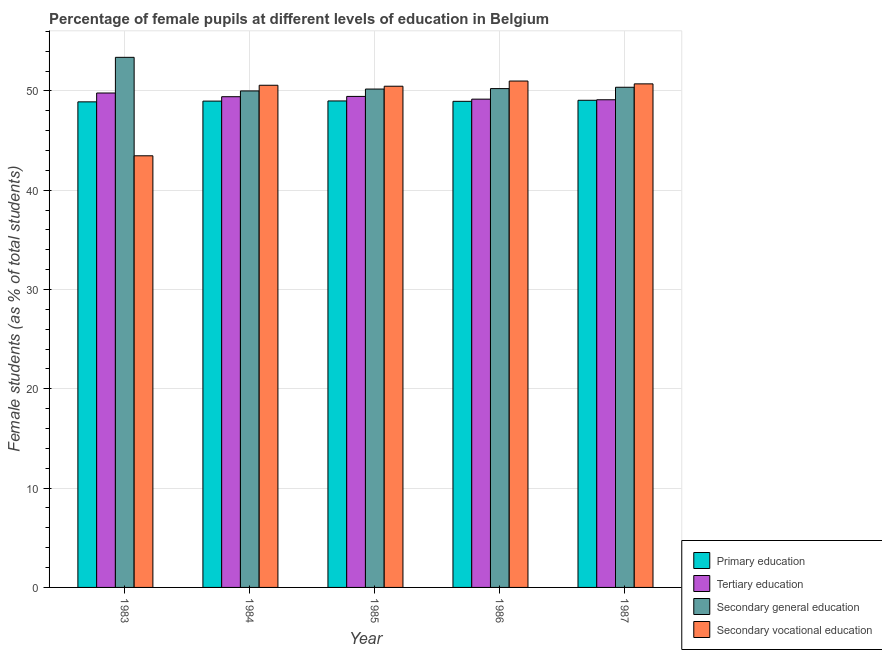How many different coloured bars are there?
Give a very brief answer. 4. How many groups of bars are there?
Provide a short and direct response. 5. Are the number of bars on each tick of the X-axis equal?
Offer a very short reply. Yes. How many bars are there on the 4th tick from the right?
Your answer should be compact. 4. What is the label of the 2nd group of bars from the left?
Provide a succinct answer. 1984. In how many cases, is the number of bars for a given year not equal to the number of legend labels?
Give a very brief answer. 0. What is the percentage of female students in primary education in 1986?
Provide a succinct answer. 48.95. Across all years, what is the maximum percentage of female students in secondary vocational education?
Your answer should be very brief. 50.99. Across all years, what is the minimum percentage of female students in primary education?
Provide a succinct answer. 48.9. In which year was the percentage of female students in primary education maximum?
Provide a succinct answer. 1987. What is the total percentage of female students in primary education in the graph?
Provide a succinct answer. 244.87. What is the difference between the percentage of female students in secondary vocational education in 1983 and that in 1986?
Provide a succinct answer. -7.53. What is the difference between the percentage of female students in tertiary education in 1983 and the percentage of female students in secondary education in 1987?
Keep it short and to the point. 0.68. What is the average percentage of female students in primary education per year?
Offer a very short reply. 48.97. In how many years, is the percentage of female students in tertiary education greater than 26 %?
Your answer should be compact. 5. What is the ratio of the percentage of female students in secondary education in 1985 to that in 1987?
Make the answer very short. 1. Is the difference between the percentage of female students in tertiary education in 1984 and 1985 greater than the difference between the percentage of female students in secondary education in 1984 and 1985?
Keep it short and to the point. No. What is the difference between the highest and the second highest percentage of female students in secondary education?
Provide a short and direct response. 3.01. What is the difference between the highest and the lowest percentage of female students in secondary vocational education?
Your response must be concise. 7.53. Is the sum of the percentage of female students in tertiary education in 1983 and 1987 greater than the maximum percentage of female students in secondary education across all years?
Provide a short and direct response. Yes. What does the 3rd bar from the left in 1986 represents?
Provide a succinct answer. Secondary general education. What does the 2nd bar from the right in 1985 represents?
Offer a terse response. Secondary general education. Are all the bars in the graph horizontal?
Ensure brevity in your answer.  No. How many years are there in the graph?
Offer a very short reply. 5. What is the difference between two consecutive major ticks on the Y-axis?
Your response must be concise. 10. Are the values on the major ticks of Y-axis written in scientific E-notation?
Ensure brevity in your answer.  No. Does the graph contain any zero values?
Your answer should be compact. No. Does the graph contain grids?
Your response must be concise. Yes. Where does the legend appear in the graph?
Provide a short and direct response. Bottom right. How many legend labels are there?
Make the answer very short. 4. How are the legend labels stacked?
Make the answer very short. Vertical. What is the title of the graph?
Give a very brief answer. Percentage of female pupils at different levels of education in Belgium. What is the label or title of the X-axis?
Provide a short and direct response. Year. What is the label or title of the Y-axis?
Give a very brief answer. Female students (as % of total students). What is the Female students (as % of total students) in Primary education in 1983?
Offer a terse response. 48.9. What is the Female students (as % of total students) in Tertiary education in 1983?
Your answer should be very brief. 49.79. What is the Female students (as % of total students) in Secondary general education in 1983?
Provide a succinct answer. 53.38. What is the Female students (as % of total students) in Secondary vocational education in 1983?
Your response must be concise. 43.47. What is the Female students (as % of total students) in Primary education in 1984?
Keep it short and to the point. 48.97. What is the Female students (as % of total students) of Tertiary education in 1984?
Provide a short and direct response. 49.42. What is the Female students (as % of total students) in Secondary general education in 1984?
Ensure brevity in your answer.  50. What is the Female students (as % of total students) of Secondary vocational education in 1984?
Make the answer very short. 50.57. What is the Female students (as % of total students) in Primary education in 1985?
Offer a terse response. 48.99. What is the Female students (as % of total students) of Tertiary education in 1985?
Ensure brevity in your answer.  49.45. What is the Female students (as % of total students) in Secondary general education in 1985?
Your answer should be very brief. 50.19. What is the Female students (as % of total students) of Secondary vocational education in 1985?
Offer a terse response. 50.47. What is the Female students (as % of total students) in Primary education in 1986?
Your answer should be very brief. 48.95. What is the Female students (as % of total students) in Tertiary education in 1986?
Provide a short and direct response. 49.17. What is the Female students (as % of total students) in Secondary general education in 1986?
Your answer should be very brief. 50.23. What is the Female students (as % of total students) of Secondary vocational education in 1986?
Your answer should be very brief. 50.99. What is the Female students (as % of total students) of Primary education in 1987?
Your answer should be very brief. 49.06. What is the Female students (as % of total students) in Tertiary education in 1987?
Give a very brief answer. 49.11. What is the Female students (as % of total students) of Secondary general education in 1987?
Your answer should be compact. 50.37. What is the Female students (as % of total students) in Secondary vocational education in 1987?
Offer a very short reply. 50.71. Across all years, what is the maximum Female students (as % of total students) of Primary education?
Your answer should be very brief. 49.06. Across all years, what is the maximum Female students (as % of total students) in Tertiary education?
Your response must be concise. 49.79. Across all years, what is the maximum Female students (as % of total students) in Secondary general education?
Offer a terse response. 53.38. Across all years, what is the maximum Female students (as % of total students) in Secondary vocational education?
Provide a short and direct response. 50.99. Across all years, what is the minimum Female students (as % of total students) in Primary education?
Make the answer very short. 48.9. Across all years, what is the minimum Female students (as % of total students) in Tertiary education?
Your answer should be very brief. 49.11. Across all years, what is the minimum Female students (as % of total students) in Secondary general education?
Provide a succinct answer. 50. Across all years, what is the minimum Female students (as % of total students) in Secondary vocational education?
Ensure brevity in your answer.  43.47. What is the total Female students (as % of total students) in Primary education in the graph?
Offer a very short reply. 244.87. What is the total Female students (as % of total students) in Tertiary education in the graph?
Give a very brief answer. 246.93. What is the total Female students (as % of total students) in Secondary general education in the graph?
Keep it short and to the point. 254.16. What is the total Female students (as % of total students) of Secondary vocational education in the graph?
Provide a succinct answer. 246.21. What is the difference between the Female students (as % of total students) of Primary education in 1983 and that in 1984?
Offer a very short reply. -0.08. What is the difference between the Female students (as % of total students) in Tertiary education in 1983 and that in 1984?
Keep it short and to the point. 0.37. What is the difference between the Female students (as % of total students) of Secondary general education in 1983 and that in 1984?
Keep it short and to the point. 3.38. What is the difference between the Female students (as % of total students) in Secondary vocational education in 1983 and that in 1984?
Ensure brevity in your answer.  -7.1. What is the difference between the Female students (as % of total students) of Primary education in 1983 and that in 1985?
Provide a short and direct response. -0.09. What is the difference between the Female students (as % of total students) of Tertiary education in 1983 and that in 1985?
Provide a succinct answer. 0.34. What is the difference between the Female students (as % of total students) in Secondary general education in 1983 and that in 1985?
Provide a short and direct response. 3.19. What is the difference between the Female students (as % of total students) in Secondary vocational education in 1983 and that in 1985?
Your response must be concise. -7.01. What is the difference between the Female students (as % of total students) in Primary education in 1983 and that in 1986?
Ensure brevity in your answer.  -0.05. What is the difference between the Female students (as % of total students) of Tertiary education in 1983 and that in 1986?
Ensure brevity in your answer.  0.62. What is the difference between the Female students (as % of total students) of Secondary general education in 1983 and that in 1986?
Your answer should be compact. 3.15. What is the difference between the Female students (as % of total students) in Secondary vocational education in 1983 and that in 1986?
Your answer should be compact. -7.53. What is the difference between the Female students (as % of total students) in Primary education in 1983 and that in 1987?
Your answer should be very brief. -0.16. What is the difference between the Female students (as % of total students) in Tertiary education in 1983 and that in 1987?
Provide a succinct answer. 0.68. What is the difference between the Female students (as % of total students) in Secondary general education in 1983 and that in 1987?
Give a very brief answer. 3.01. What is the difference between the Female students (as % of total students) of Secondary vocational education in 1983 and that in 1987?
Give a very brief answer. -7.24. What is the difference between the Female students (as % of total students) of Primary education in 1984 and that in 1985?
Ensure brevity in your answer.  -0.01. What is the difference between the Female students (as % of total students) in Tertiary education in 1984 and that in 1985?
Make the answer very short. -0.03. What is the difference between the Female students (as % of total students) in Secondary general education in 1984 and that in 1985?
Provide a succinct answer. -0.19. What is the difference between the Female students (as % of total students) in Secondary vocational education in 1984 and that in 1985?
Your response must be concise. 0.1. What is the difference between the Female students (as % of total students) in Primary education in 1984 and that in 1986?
Keep it short and to the point. 0.02. What is the difference between the Female students (as % of total students) in Tertiary education in 1984 and that in 1986?
Your answer should be very brief. 0.25. What is the difference between the Female students (as % of total students) in Secondary general education in 1984 and that in 1986?
Ensure brevity in your answer.  -0.23. What is the difference between the Female students (as % of total students) of Secondary vocational education in 1984 and that in 1986?
Keep it short and to the point. -0.42. What is the difference between the Female students (as % of total students) of Primary education in 1984 and that in 1987?
Your answer should be compact. -0.08. What is the difference between the Female students (as % of total students) of Tertiary education in 1984 and that in 1987?
Make the answer very short. 0.31. What is the difference between the Female students (as % of total students) in Secondary general education in 1984 and that in 1987?
Make the answer very short. -0.37. What is the difference between the Female students (as % of total students) of Secondary vocational education in 1984 and that in 1987?
Your answer should be compact. -0.14. What is the difference between the Female students (as % of total students) of Primary education in 1985 and that in 1986?
Make the answer very short. 0.04. What is the difference between the Female students (as % of total students) of Tertiary education in 1985 and that in 1986?
Provide a succinct answer. 0.28. What is the difference between the Female students (as % of total students) of Secondary general education in 1985 and that in 1986?
Ensure brevity in your answer.  -0.05. What is the difference between the Female students (as % of total students) in Secondary vocational education in 1985 and that in 1986?
Your response must be concise. -0.52. What is the difference between the Female students (as % of total students) of Primary education in 1985 and that in 1987?
Keep it short and to the point. -0.07. What is the difference between the Female students (as % of total students) in Tertiary education in 1985 and that in 1987?
Give a very brief answer. 0.34. What is the difference between the Female students (as % of total students) of Secondary general education in 1985 and that in 1987?
Your answer should be very brief. -0.18. What is the difference between the Female students (as % of total students) in Secondary vocational education in 1985 and that in 1987?
Keep it short and to the point. -0.24. What is the difference between the Female students (as % of total students) of Primary education in 1986 and that in 1987?
Give a very brief answer. -0.1. What is the difference between the Female students (as % of total students) in Tertiary education in 1986 and that in 1987?
Your answer should be very brief. 0.06. What is the difference between the Female students (as % of total students) in Secondary general education in 1986 and that in 1987?
Offer a terse response. -0.13. What is the difference between the Female students (as % of total students) in Secondary vocational education in 1986 and that in 1987?
Provide a succinct answer. 0.29. What is the difference between the Female students (as % of total students) of Primary education in 1983 and the Female students (as % of total students) of Tertiary education in 1984?
Offer a very short reply. -0.52. What is the difference between the Female students (as % of total students) in Primary education in 1983 and the Female students (as % of total students) in Secondary general education in 1984?
Make the answer very short. -1.1. What is the difference between the Female students (as % of total students) in Primary education in 1983 and the Female students (as % of total students) in Secondary vocational education in 1984?
Your answer should be compact. -1.67. What is the difference between the Female students (as % of total students) in Tertiary education in 1983 and the Female students (as % of total students) in Secondary general education in 1984?
Make the answer very short. -0.21. What is the difference between the Female students (as % of total students) of Tertiary education in 1983 and the Female students (as % of total students) of Secondary vocational education in 1984?
Provide a succinct answer. -0.78. What is the difference between the Female students (as % of total students) of Secondary general education in 1983 and the Female students (as % of total students) of Secondary vocational education in 1984?
Ensure brevity in your answer.  2.81. What is the difference between the Female students (as % of total students) in Primary education in 1983 and the Female students (as % of total students) in Tertiary education in 1985?
Keep it short and to the point. -0.55. What is the difference between the Female students (as % of total students) in Primary education in 1983 and the Female students (as % of total students) in Secondary general education in 1985?
Your answer should be compact. -1.29. What is the difference between the Female students (as % of total students) of Primary education in 1983 and the Female students (as % of total students) of Secondary vocational education in 1985?
Offer a terse response. -1.57. What is the difference between the Female students (as % of total students) in Tertiary education in 1983 and the Female students (as % of total students) in Secondary general education in 1985?
Your answer should be compact. -0.4. What is the difference between the Female students (as % of total students) of Tertiary education in 1983 and the Female students (as % of total students) of Secondary vocational education in 1985?
Offer a terse response. -0.68. What is the difference between the Female students (as % of total students) of Secondary general education in 1983 and the Female students (as % of total students) of Secondary vocational education in 1985?
Your answer should be compact. 2.91. What is the difference between the Female students (as % of total students) in Primary education in 1983 and the Female students (as % of total students) in Tertiary education in 1986?
Your answer should be very brief. -0.27. What is the difference between the Female students (as % of total students) in Primary education in 1983 and the Female students (as % of total students) in Secondary general education in 1986?
Your answer should be compact. -1.33. What is the difference between the Female students (as % of total students) in Primary education in 1983 and the Female students (as % of total students) in Secondary vocational education in 1986?
Provide a short and direct response. -2.1. What is the difference between the Female students (as % of total students) of Tertiary education in 1983 and the Female students (as % of total students) of Secondary general education in 1986?
Ensure brevity in your answer.  -0.44. What is the difference between the Female students (as % of total students) in Tertiary education in 1983 and the Female students (as % of total students) in Secondary vocational education in 1986?
Your answer should be compact. -1.21. What is the difference between the Female students (as % of total students) of Secondary general education in 1983 and the Female students (as % of total students) of Secondary vocational education in 1986?
Ensure brevity in your answer.  2.39. What is the difference between the Female students (as % of total students) of Primary education in 1983 and the Female students (as % of total students) of Tertiary education in 1987?
Offer a very short reply. -0.21. What is the difference between the Female students (as % of total students) of Primary education in 1983 and the Female students (as % of total students) of Secondary general education in 1987?
Give a very brief answer. -1.47. What is the difference between the Female students (as % of total students) in Primary education in 1983 and the Female students (as % of total students) in Secondary vocational education in 1987?
Ensure brevity in your answer.  -1.81. What is the difference between the Female students (as % of total students) in Tertiary education in 1983 and the Female students (as % of total students) in Secondary general education in 1987?
Make the answer very short. -0.58. What is the difference between the Female students (as % of total students) of Tertiary education in 1983 and the Female students (as % of total students) of Secondary vocational education in 1987?
Your response must be concise. -0.92. What is the difference between the Female students (as % of total students) of Secondary general education in 1983 and the Female students (as % of total students) of Secondary vocational education in 1987?
Make the answer very short. 2.67. What is the difference between the Female students (as % of total students) in Primary education in 1984 and the Female students (as % of total students) in Tertiary education in 1985?
Provide a short and direct response. -0.47. What is the difference between the Female students (as % of total students) of Primary education in 1984 and the Female students (as % of total students) of Secondary general education in 1985?
Ensure brevity in your answer.  -1.21. What is the difference between the Female students (as % of total students) of Primary education in 1984 and the Female students (as % of total students) of Secondary vocational education in 1985?
Give a very brief answer. -1.5. What is the difference between the Female students (as % of total students) in Tertiary education in 1984 and the Female students (as % of total students) in Secondary general education in 1985?
Give a very brief answer. -0.77. What is the difference between the Female students (as % of total students) in Tertiary education in 1984 and the Female students (as % of total students) in Secondary vocational education in 1985?
Give a very brief answer. -1.06. What is the difference between the Female students (as % of total students) of Secondary general education in 1984 and the Female students (as % of total students) of Secondary vocational education in 1985?
Ensure brevity in your answer.  -0.47. What is the difference between the Female students (as % of total students) in Primary education in 1984 and the Female students (as % of total students) in Tertiary education in 1986?
Provide a succinct answer. -0.2. What is the difference between the Female students (as % of total students) of Primary education in 1984 and the Female students (as % of total students) of Secondary general education in 1986?
Offer a terse response. -1.26. What is the difference between the Female students (as % of total students) in Primary education in 1984 and the Female students (as % of total students) in Secondary vocational education in 1986?
Keep it short and to the point. -2.02. What is the difference between the Female students (as % of total students) of Tertiary education in 1984 and the Female students (as % of total students) of Secondary general education in 1986?
Keep it short and to the point. -0.82. What is the difference between the Female students (as % of total students) in Tertiary education in 1984 and the Female students (as % of total students) in Secondary vocational education in 1986?
Provide a short and direct response. -1.58. What is the difference between the Female students (as % of total students) of Secondary general education in 1984 and the Female students (as % of total students) of Secondary vocational education in 1986?
Your response must be concise. -1. What is the difference between the Female students (as % of total students) of Primary education in 1984 and the Female students (as % of total students) of Tertiary education in 1987?
Give a very brief answer. -0.13. What is the difference between the Female students (as % of total students) in Primary education in 1984 and the Female students (as % of total students) in Secondary general education in 1987?
Your answer should be compact. -1.39. What is the difference between the Female students (as % of total students) of Primary education in 1984 and the Female students (as % of total students) of Secondary vocational education in 1987?
Offer a very short reply. -1.73. What is the difference between the Female students (as % of total students) in Tertiary education in 1984 and the Female students (as % of total students) in Secondary general education in 1987?
Your answer should be very brief. -0.95. What is the difference between the Female students (as % of total students) in Tertiary education in 1984 and the Female students (as % of total students) in Secondary vocational education in 1987?
Provide a succinct answer. -1.29. What is the difference between the Female students (as % of total students) of Secondary general education in 1984 and the Female students (as % of total students) of Secondary vocational education in 1987?
Provide a short and direct response. -0.71. What is the difference between the Female students (as % of total students) of Primary education in 1985 and the Female students (as % of total students) of Tertiary education in 1986?
Keep it short and to the point. -0.18. What is the difference between the Female students (as % of total students) of Primary education in 1985 and the Female students (as % of total students) of Secondary general education in 1986?
Keep it short and to the point. -1.24. What is the difference between the Female students (as % of total students) of Primary education in 1985 and the Female students (as % of total students) of Secondary vocational education in 1986?
Keep it short and to the point. -2.01. What is the difference between the Female students (as % of total students) of Tertiary education in 1985 and the Female students (as % of total students) of Secondary general education in 1986?
Your answer should be very brief. -0.79. What is the difference between the Female students (as % of total students) of Tertiary education in 1985 and the Female students (as % of total students) of Secondary vocational education in 1986?
Offer a very short reply. -1.55. What is the difference between the Female students (as % of total students) of Secondary general education in 1985 and the Female students (as % of total students) of Secondary vocational education in 1986?
Your answer should be very brief. -0.81. What is the difference between the Female students (as % of total students) of Primary education in 1985 and the Female students (as % of total students) of Tertiary education in 1987?
Your response must be concise. -0.12. What is the difference between the Female students (as % of total students) of Primary education in 1985 and the Female students (as % of total students) of Secondary general education in 1987?
Offer a terse response. -1.38. What is the difference between the Female students (as % of total students) in Primary education in 1985 and the Female students (as % of total students) in Secondary vocational education in 1987?
Make the answer very short. -1.72. What is the difference between the Female students (as % of total students) of Tertiary education in 1985 and the Female students (as % of total students) of Secondary general education in 1987?
Offer a very short reply. -0.92. What is the difference between the Female students (as % of total students) in Tertiary education in 1985 and the Female students (as % of total students) in Secondary vocational education in 1987?
Your response must be concise. -1.26. What is the difference between the Female students (as % of total students) in Secondary general education in 1985 and the Female students (as % of total students) in Secondary vocational education in 1987?
Ensure brevity in your answer.  -0.52. What is the difference between the Female students (as % of total students) in Primary education in 1986 and the Female students (as % of total students) in Tertiary education in 1987?
Ensure brevity in your answer.  -0.16. What is the difference between the Female students (as % of total students) in Primary education in 1986 and the Female students (as % of total students) in Secondary general education in 1987?
Provide a succinct answer. -1.42. What is the difference between the Female students (as % of total students) in Primary education in 1986 and the Female students (as % of total students) in Secondary vocational education in 1987?
Your response must be concise. -1.76. What is the difference between the Female students (as % of total students) in Tertiary education in 1986 and the Female students (as % of total students) in Secondary general education in 1987?
Keep it short and to the point. -1.2. What is the difference between the Female students (as % of total students) in Tertiary education in 1986 and the Female students (as % of total students) in Secondary vocational education in 1987?
Provide a succinct answer. -1.54. What is the difference between the Female students (as % of total students) in Secondary general education in 1986 and the Female students (as % of total students) in Secondary vocational education in 1987?
Provide a short and direct response. -0.48. What is the average Female students (as % of total students) of Primary education per year?
Make the answer very short. 48.97. What is the average Female students (as % of total students) of Tertiary education per year?
Keep it short and to the point. 49.39. What is the average Female students (as % of total students) of Secondary general education per year?
Ensure brevity in your answer.  50.83. What is the average Female students (as % of total students) of Secondary vocational education per year?
Provide a short and direct response. 49.24. In the year 1983, what is the difference between the Female students (as % of total students) of Primary education and Female students (as % of total students) of Tertiary education?
Ensure brevity in your answer.  -0.89. In the year 1983, what is the difference between the Female students (as % of total students) of Primary education and Female students (as % of total students) of Secondary general education?
Offer a terse response. -4.48. In the year 1983, what is the difference between the Female students (as % of total students) in Primary education and Female students (as % of total students) in Secondary vocational education?
Give a very brief answer. 5.43. In the year 1983, what is the difference between the Female students (as % of total students) of Tertiary education and Female students (as % of total students) of Secondary general education?
Ensure brevity in your answer.  -3.59. In the year 1983, what is the difference between the Female students (as % of total students) in Tertiary education and Female students (as % of total students) in Secondary vocational education?
Provide a succinct answer. 6.32. In the year 1983, what is the difference between the Female students (as % of total students) of Secondary general education and Female students (as % of total students) of Secondary vocational education?
Make the answer very short. 9.92. In the year 1984, what is the difference between the Female students (as % of total students) of Primary education and Female students (as % of total students) of Tertiary education?
Ensure brevity in your answer.  -0.44. In the year 1984, what is the difference between the Female students (as % of total students) of Primary education and Female students (as % of total students) of Secondary general education?
Give a very brief answer. -1.02. In the year 1984, what is the difference between the Female students (as % of total students) of Primary education and Female students (as % of total students) of Secondary vocational education?
Ensure brevity in your answer.  -1.59. In the year 1984, what is the difference between the Female students (as % of total students) in Tertiary education and Female students (as % of total students) in Secondary general education?
Provide a short and direct response. -0.58. In the year 1984, what is the difference between the Female students (as % of total students) of Tertiary education and Female students (as % of total students) of Secondary vocational education?
Your answer should be very brief. -1.15. In the year 1984, what is the difference between the Female students (as % of total students) of Secondary general education and Female students (as % of total students) of Secondary vocational education?
Your answer should be very brief. -0.57. In the year 1985, what is the difference between the Female students (as % of total students) of Primary education and Female students (as % of total students) of Tertiary education?
Provide a short and direct response. -0.46. In the year 1985, what is the difference between the Female students (as % of total students) in Primary education and Female students (as % of total students) in Secondary general education?
Offer a terse response. -1.2. In the year 1985, what is the difference between the Female students (as % of total students) in Primary education and Female students (as % of total students) in Secondary vocational education?
Offer a very short reply. -1.48. In the year 1985, what is the difference between the Female students (as % of total students) in Tertiary education and Female students (as % of total students) in Secondary general education?
Provide a succinct answer. -0.74. In the year 1985, what is the difference between the Female students (as % of total students) in Tertiary education and Female students (as % of total students) in Secondary vocational education?
Provide a short and direct response. -1.03. In the year 1985, what is the difference between the Female students (as % of total students) in Secondary general education and Female students (as % of total students) in Secondary vocational education?
Keep it short and to the point. -0.28. In the year 1986, what is the difference between the Female students (as % of total students) of Primary education and Female students (as % of total students) of Tertiary education?
Offer a very short reply. -0.22. In the year 1986, what is the difference between the Female students (as % of total students) of Primary education and Female students (as % of total students) of Secondary general education?
Your answer should be compact. -1.28. In the year 1986, what is the difference between the Female students (as % of total students) of Primary education and Female students (as % of total students) of Secondary vocational education?
Provide a short and direct response. -2.04. In the year 1986, what is the difference between the Female students (as % of total students) in Tertiary education and Female students (as % of total students) in Secondary general education?
Make the answer very short. -1.06. In the year 1986, what is the difference between the Female students (as % of total students) in Tertiary education and Female students (as % of total students) in Secondary vocational education?
Keep it short and to the point. -1.82. In the year 1986, what is the difference between the Female students (as % of total students) of Secondary general education and Female students (as % of total students) of Secondary vocational education?
Ensure brevity in your answer.  -0.76. In the year 1987, what is the difference between the Female students (as % of total students) in Primary education and Female students (as % of total students) in Tertiary education?
Make the answer very short. -0.05. In the year 1987, what is the difference between the Female students (as % of total students) in Primary education and Female students (as % of total students) in Secondary general education?
Your answer should be very brief. -1.31. In the year 1987, what is the difference between the Female students (as % of total students) in Primary education and Female students (as % of total students) in Secondary vocational education?
Make the answer very short. -1.65. In the year 1987, what is the difference between the Female students (as % of total students) in Tertiary education and Female students (as % of total students) in Secondary general education?
Your answer should be very brief. -1.26. In the year 1987, what is the difference between the Female students (as % of total students) of Tertiary education and Female students (as % of total students) of Secondary vocational education?
Give a very brief answer. -1.6. In the year 1987, what is the difference between the Female students (as % of total students) of Secondary general education and Female students (as % of total students) of Secondary vocational education?
Your answer should be compact. -0.34. What is the ratio of the Female students (as % of total students) of Tertiary education in 1983 to that in 1984?
Give a very brief answer. 1.01. What is the ratio of the Female students (as % of total students) in Secondary general education in 1983 to that in 1984?
Your answer should be very brief. 1.07. What is the ratio of the Female students (as % of total students) in Secondary vocational education in 1983 to that in 1984?
Your answer should be compact. 0.86. What is the ratio of the Female students (as % of total students) in Tertiary education in 1983 to that in 1985?
Your response must be concise. 1.01. What is the ratio of the Female students (as % of total students) of Secondary general education in 1983 to that in 1985?
Offer a very short reply. 1.06. What is the ratio of the Female students (as % of total students) of Secondary vocational education in 1983 to that in 1985?
Ensure brevity in your answer.  0.86. What is the ratio of the Female students (as % of total students) in Tertiary education in 1983 to that in 1986?
Ensure brevity in your answer.  1.01. What is the ratio of the Female students (as % of total students) of Secondary general education in 1983 to that in 1986?
Your response must be concise. 1.06. What is the ratio of the Female students (as % of total students) of Secondary vocational education in 1983 to that in 1986?
Your answer should be very brief. 0.85. What is the ratio of the Female students (as % of total students) in Primary education in 1983 to that in 1987?
Provide a short and direct response. 1. What is the ratio of the Female students (as % of total students) of Tertiary education in 1983 to that in 1987?
Provide a short and direct response. 1.01. What is the ratio of the Female students (as % of total students) of Secondary general education in 1983 to that in 1987?
Your response must be concise. 1.06. What is the ratio of the Female students (as % of total students) in Secondary vocational education in 1983 to that in 1987?
Offer a terse response. 0.86. What is the ratio of the Female students (as % of total students) in Primary education in 1984 to that in 1985?
Offer a terse response. 1. What is the ratio of the Female students (as % of total students) of Tertiary education in 1984 to that in 1985?
Your answer should be very brief. 1. What is the ratio of the Female students (as % of total students) in Secondary vocational education in 1984 to that in 1985?
Your answer should be very brief. 1. What is the ratio of the Female students (as % of total students) in Tertiary education in 1984 to that in 1986?
Provide a succinct answer. 1. What is the ratio of the Female students (as % of total students) in Secondary general education in 1984 to that in 1986?
Keep it short and to the point. 1. What is the ratio of the Female students (as % of total students) of Primary education in 1984 to that in 1987?
Make the answer very short. 1. What is the ratio of the Female students (as % of total students) in Secondary general education in 1984 to that in 1987?
Provide a succinct answer. 0.99. What is the ratio of the Female students (as % of total students) in Secondary vocational education in 1984 to that in 1987?
Provide a short and direct response. 1. What is the ratio of the Female students (as % of total students) in Tertiary education in 1985 to that in 1986?
Provide a short and direct response. 1.01. What is the ratio of the Female students (as % of total students) in Secondary general education in 1985 to that in 1986?
Offer a very short reply. 1. What is the ratio of the Female students (as % of total students) of Tertiary education in 1985 to that in 1987?
Make the answer very short. 1.01. What is the ratio of the Female students (as % of total students) of Secondary general education in 1986 to that in 1987?
Your answer should be compact. 1. What is the ratio of the Female students (as % of total students) in Secondary vocational education in 1986 to that in 1987?
Provide a short and direct response. 1.01. What is the difference between the highest and the second highest Female students (as % of total students) in Primary education?
Offer a terse response. 0.07. What is the difference between the highest and the second highest Female students (as % of total students) of Tertiary education?
Provide a succinct answer. 0.34. What is the difference between the highest and the second highest Female students (as % of total students) in Secondary general education?
Provide a short and direct response. 3.01. What is the difference between the highest and the second highest Female students (as % of total students) in Secondary vocational education?
Offer a terse response. 0.29. What is the difference between the highest and the lowest Female students (as % of total students) in Primary education?
Keep it short and to the point. 0.16. What is the difference between the highest and the lowest Female students (as % of total students) in Tertiary education?
Offer a terse response. 0.68. What is the difference between the highest and the lowest Female students (as % of total students) in Secondary general education?
Make the answer very short. 3.38. What is the difference between the highest and the lowest Female students (as % of total students) of Secondary vocational education?
Make the answer very short. 7.53. 